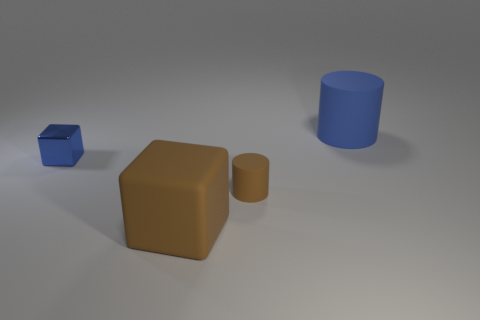Add 2 brown rubber blocks. How many objects exist? 6 Subtract all blue cubes. How many cubes are left? 1 Subtract 2 cubes. How many cubes are left? 0 Add 3 objects. How many objects exist? 7 Subtract 0 purple spheres. How many objects are left? 4 Subtract all brown cubes. Subtract all brown spheres. How many cubes are left? 1 Subtract all purple blocks. How many blue cylinders are left? 1 Subtract all blue shiny spheres. Subtract all brown matte things. How many objects are left? 2 Add 3 cylinders. How many cylinders are left? 5 